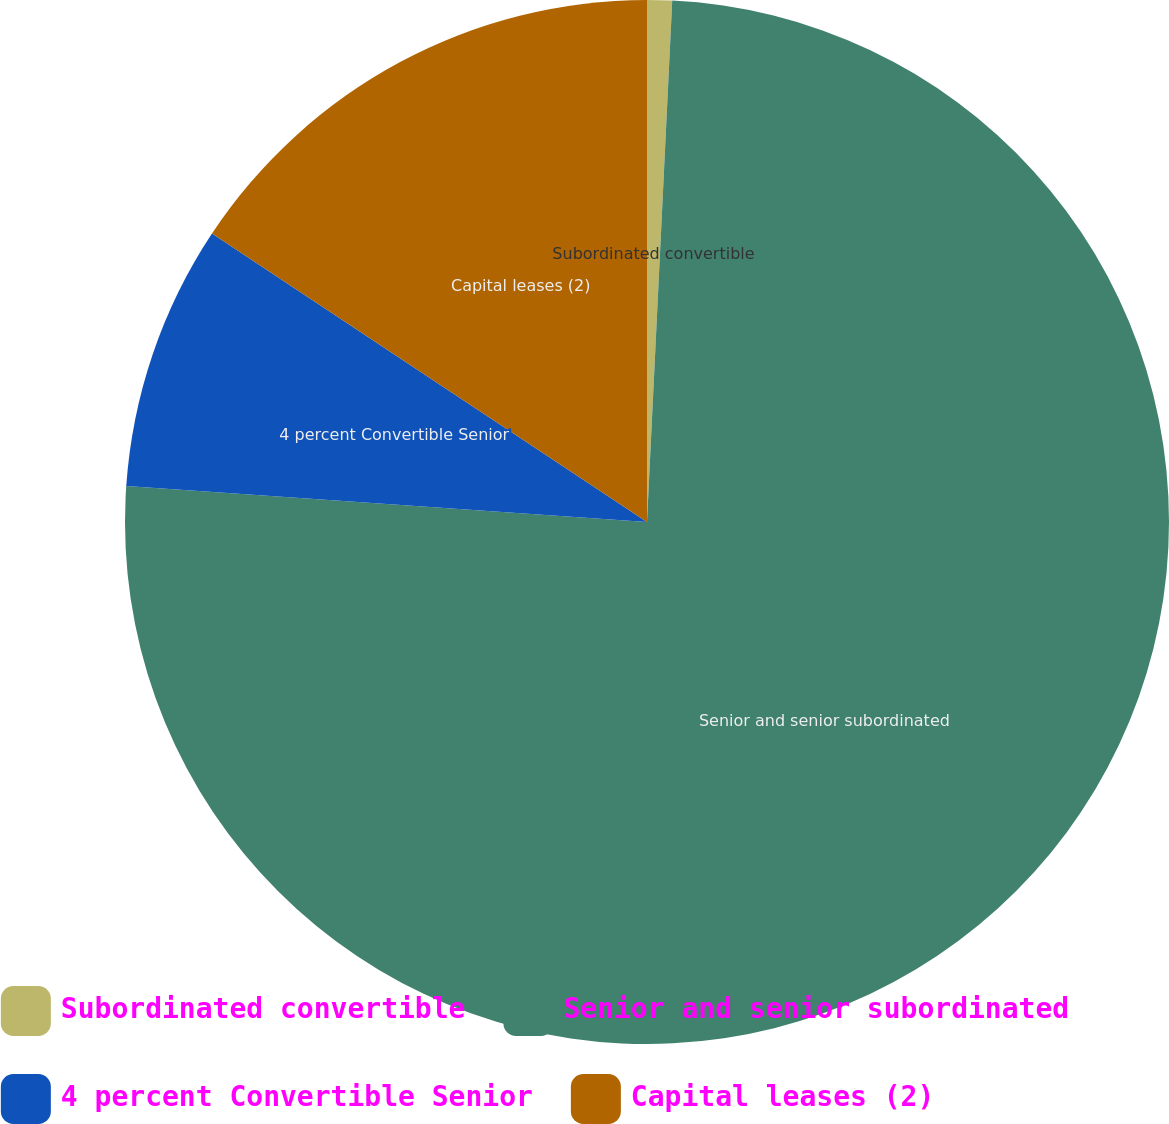Convert chart to OTSL. <chart><loc_0><loc_0><loc_500><loc_500><pie_chart><fcel>Subordinated convertible<fcel>Senior and senior subordinated<fcel>4 percent Convertible Senior<fcel>Capital leases (2)<nl><fcel>0.77%<fcel>75.33%<fcel>8.22%<fcel>15.68%<nl></chart> 